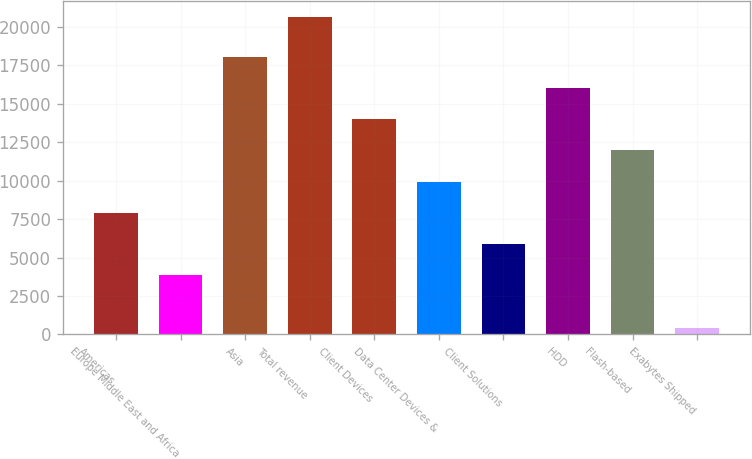Convert chart. <chart><loc_0><loc_0><loc_500><loc_500><bar_chart><fcel>Americas<fcel>Europe Middle East and Africa<fcel>Asia<fcel>Total revenue<fcel>Client Devices<fcel>Data Center Devices &<fcel>Client Solutions<fcel>HDD<fcel>Flash-based<fcel>Exabytes Shipped<nl><fcel>7909.6<fcel>3858<fcel>18038.6<fcel>20647<fcel>13987<fcel>9935.4<fcel>5883.8<fcel>16012.8<fcel>11961.2<fcel>389<nl></chart> 